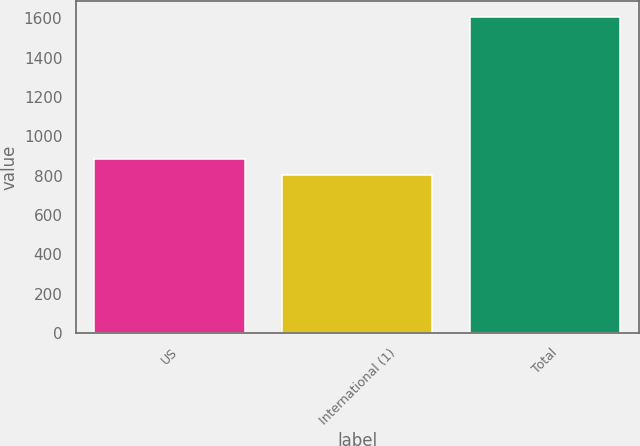Convert chart to OTSL. <chart><loc_0><loc_0><loc_500><loc_500><bar_chart><fcel>US<fcel>International (1)<fcel>Total<nl><fcel>883.6<fcel>803<fcel>1609<nl></chart> 